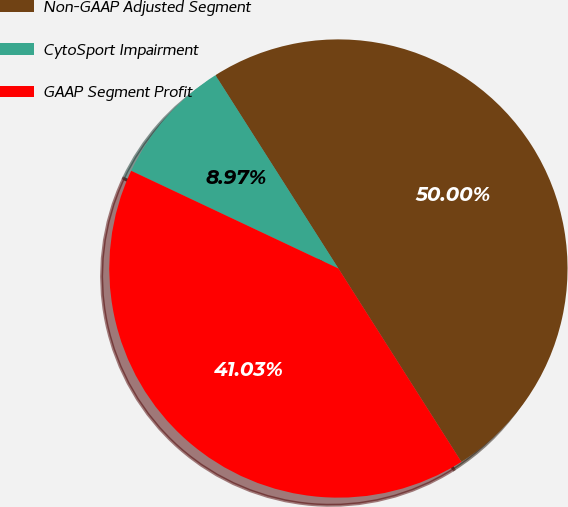Convert chart. <chart><loc_0><loc_0><loc_500><loc_500><pie_chart><fcel>Non-GAAP Adjusted Segment<fcel>CytoSport Impairment<fcel>GAAP Segment Profit<nl><fcel>50.0%<fcel>8.97%<fcel>41.03%<nl></chart> 